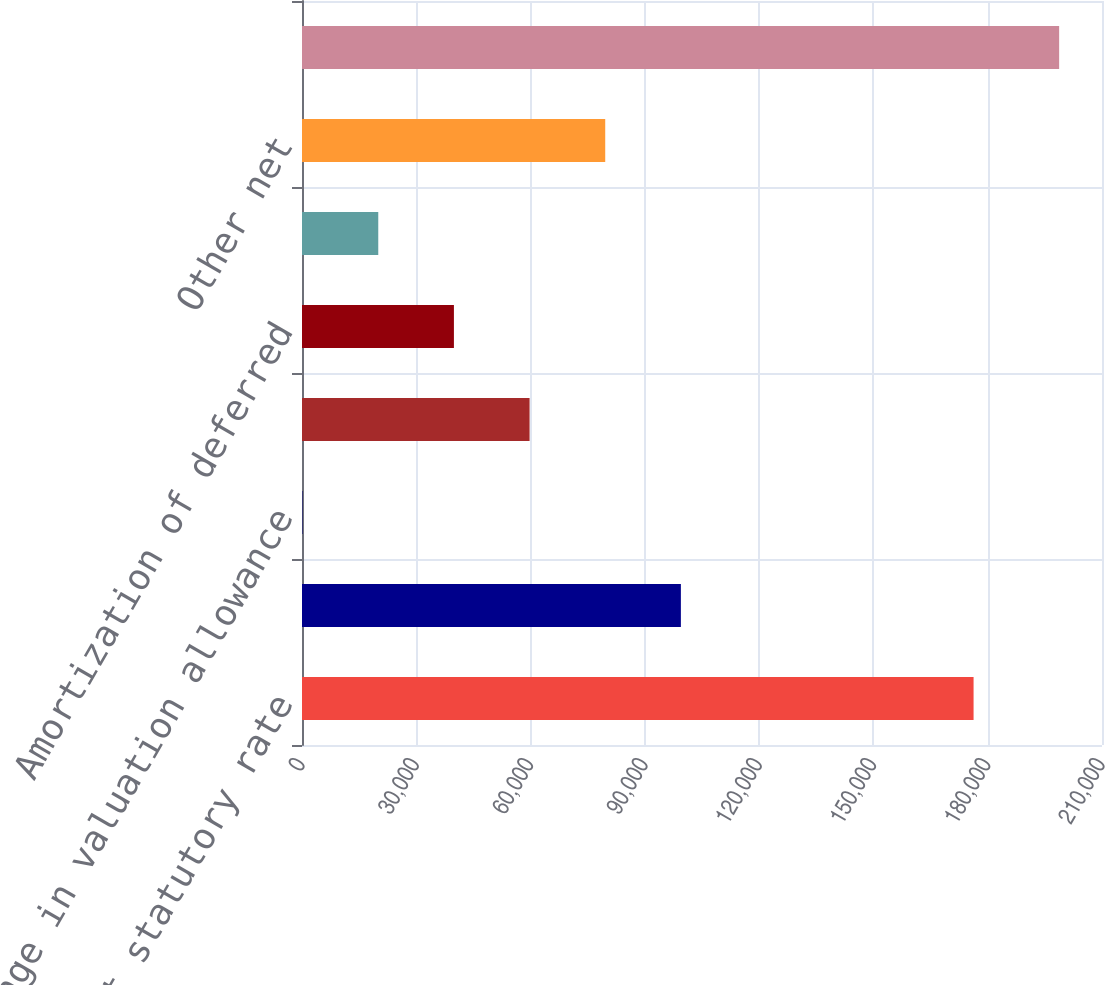Convert chart to OTSL. <chart><loc_0><loc_0><loc_500><loc_500><bar_chart><fcel>Income tax at statutory rate<fcel>State taxes net of federal<fcel>Change in valuation allowance<fcel>Flow through differences<fcel>Amortization of deferred<fcel>Subsidiary preferred dividends<fcel>Other net<fcel>Actual income tax expense<nl><fcel>176288<fcel>99455.5<fcel>160<fcel>59737.3<fcel>39878.2<fcel>20019.1<fcel>79596.4<fcel>198751<nl></chart> 